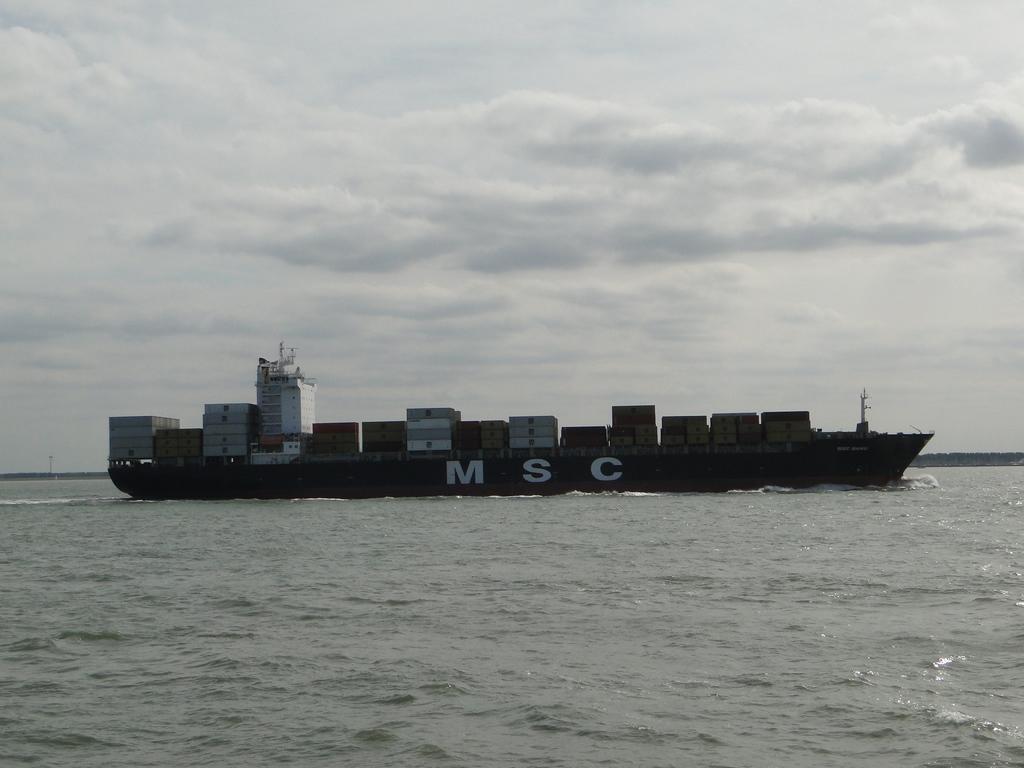In one or two sentences, can you explain what this image depicts? In this image there is a ship on the sea, in the background there is the sky. 